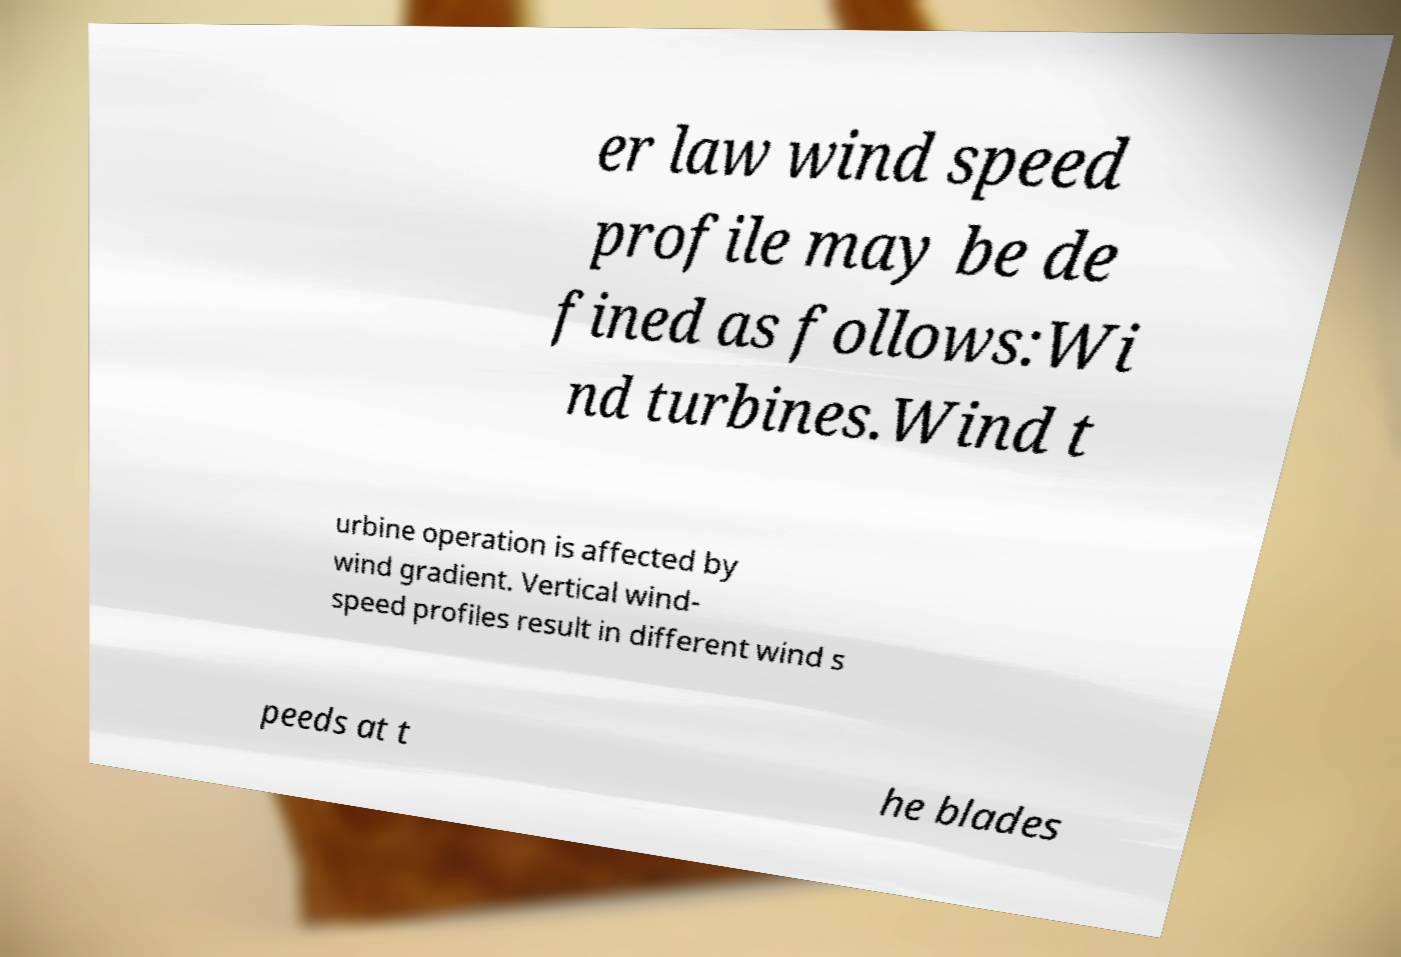I need the written content from this picture converted into text. Can you do that? er law wind speed profile may be de fined as follows:Wi nd turbines.Wind t urbine operation is affected by wind gradient. Vertical wind- speed profiles result in different wind s peeds at t he blades 